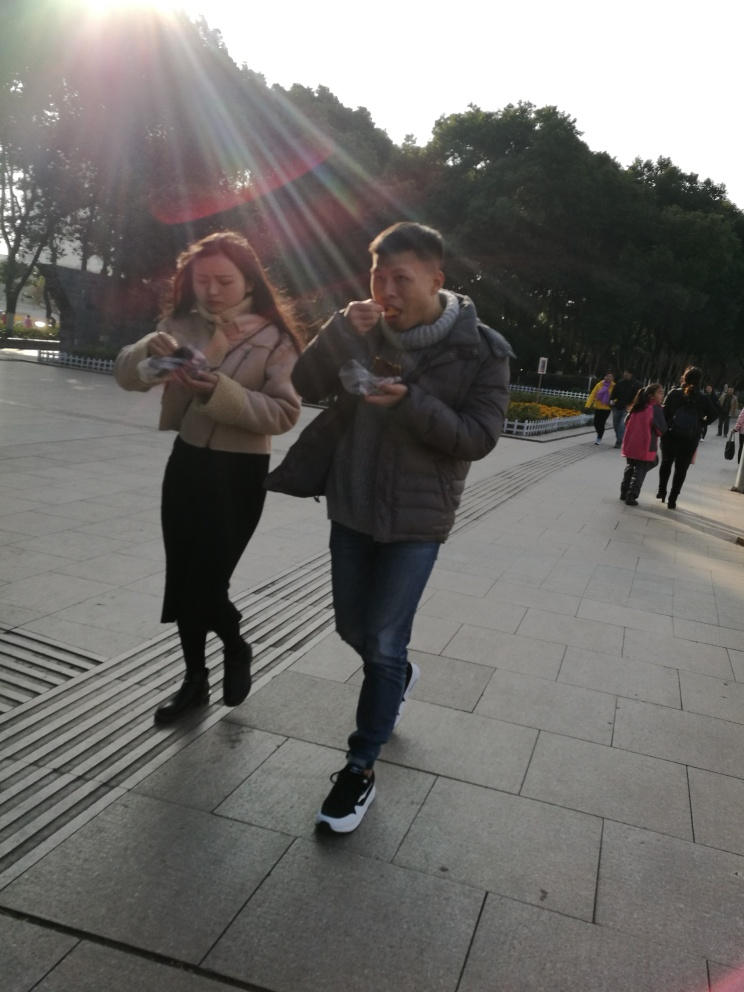Is there excessive noise in the photo?
 No 